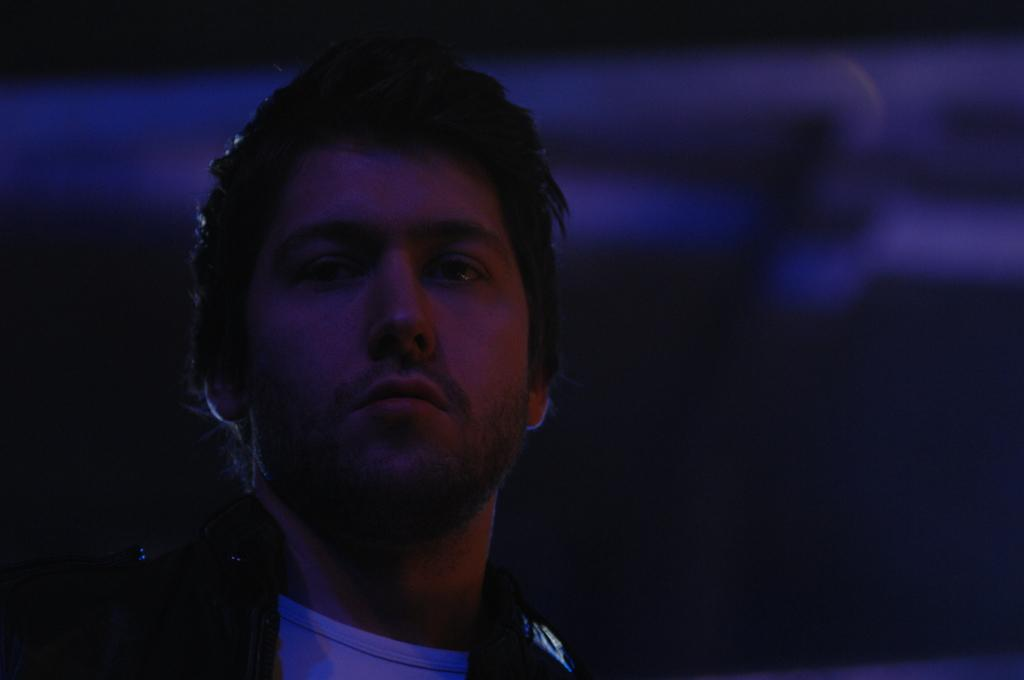What is the main subject in the foreground of the image? There is a man in the foreground of the image. Can you describe the background of the image? The background of the image is blurry. What is the condition of the cellar in the image? There is no cellar present in the image. Can you describe the man's smile in the image? The provided facts do not mention the man's facial expression, so we cannot determine if he is smiling or not. 